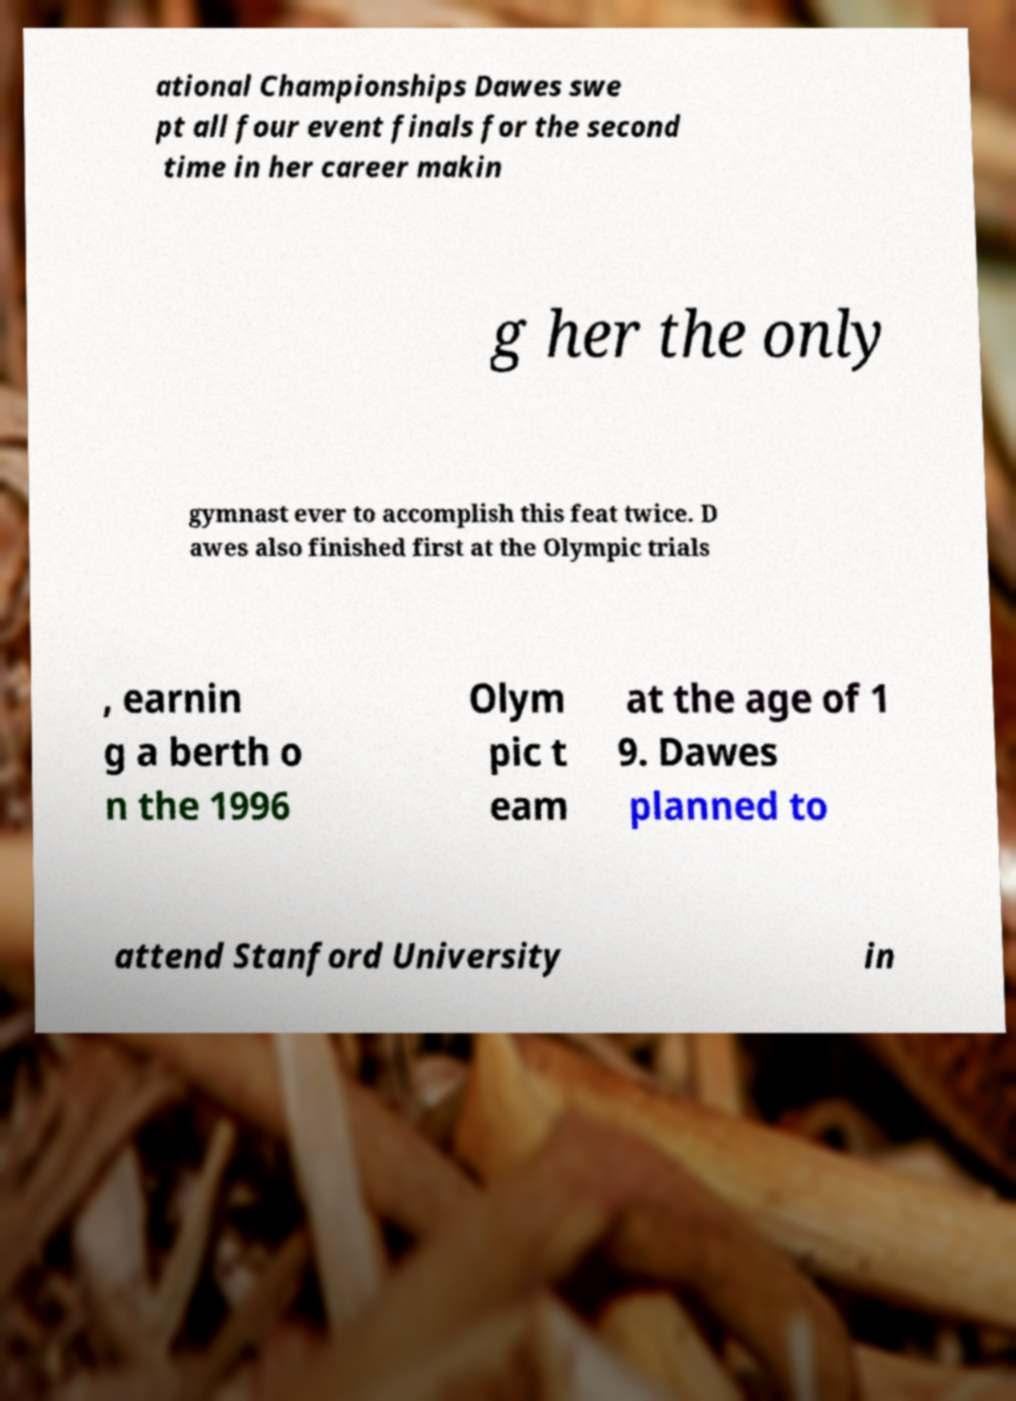Can you read and provide the text displayed in the image?This photo seems to have some interesting text. Can you extract and type it out for me? ational Championships Dawes swe pt all four event finals for the second time in her career makin g her the only gymnast ever to accomplish this feat twice. D awes also finished first at the Olympic trials , earnin g a berth o n the 1996 Olym pic t eam at the age of 1 9. Dawes planned to attend Stanford University in 